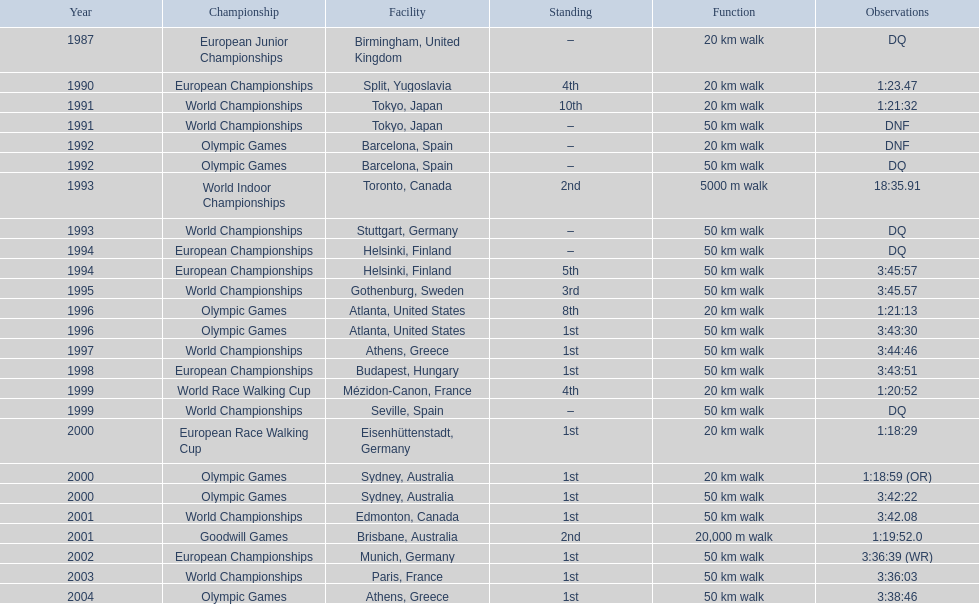What was the difference between korzeniowski's performance at the 1996 olympic games and the 2000 olympic games in the 20 km walk? 2:14. 